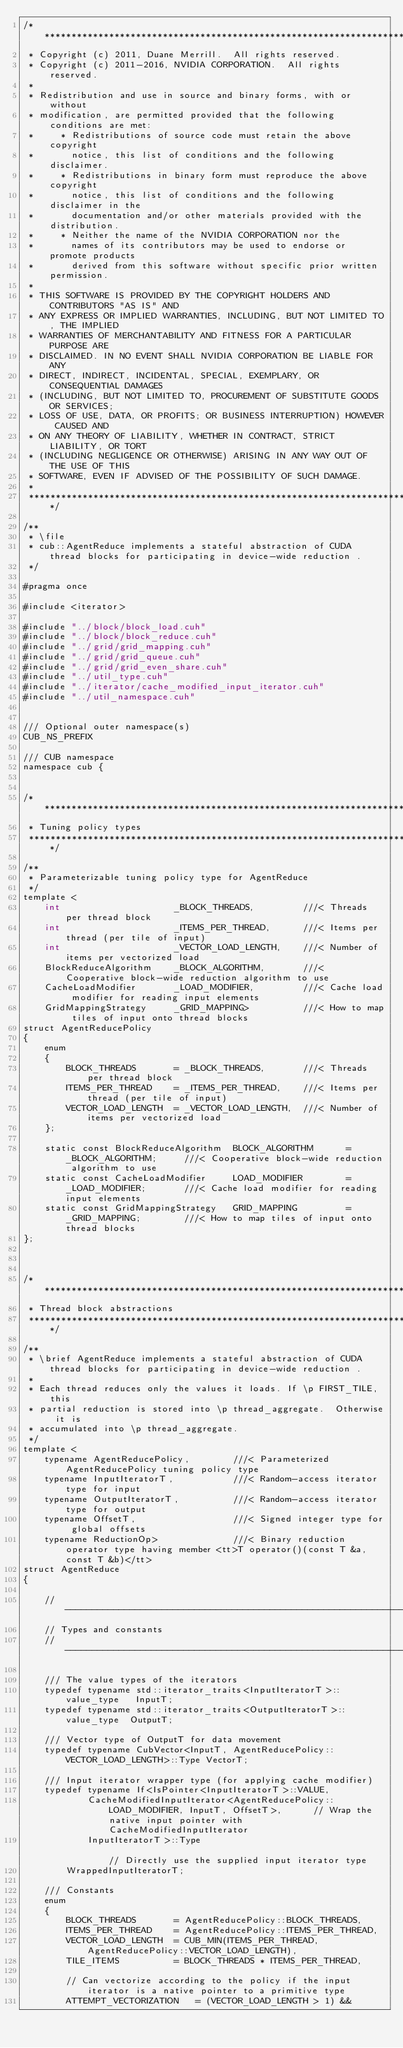Convert code to text. <code><loc_0><loc_0><loc_500><loc_500><_Cuda_>/******************************************************************************
 * Copyright (c) 2011, Duane Merrill.  All rights reserved.
 * Copyright (c) 2011-2016, NVIDIA CORPORATION.  All rights reserved.
 *
 * Redistribution and use in source and binary forms, with or without
 * modification, are permitted provided that the following conditions are met:
 *     * Redistributions of source code must retain the above copyright
 *       notice, this list of conditions and the following disclaimer.
 *     * Redistributions in binary form must reproduce the above copyright
 *       notice, this list of conditions and the following disclaimer in the
 *       documentation and/or other materials provided with the distribution.
 *     * Neither the name of the NVIDIA CORPORATION nor the
 *       names of its contributors may be used to endorse or promote products
 *       derived from this software without specific prior written permission.
 *
 * THIS SOFTWARE IS PROVIDED BY THE COPYRIGHT HOLDERS AND CONTRIBUTORS "AS IS" AND
 * ANY EXPRESS OR IMPLIED WARRANTIES, INCLUDING, BUT NOT LIMITED TO, THE IMPLIED
 * WARRANTIES OF MERCHANTABILITY AND FITNESS FOR A PARTICULAR PURPOSE ARE
 * DISCLAIMED. IN NO EVENT SHALL NVIDIA CORPORATION BE LIABLE FOR ANY
 * DIRECT, INDIRECT, INCIDENTAL, SPECIAL, EXEMPLARY, OR CONSEQUENTIAL DAMAGES
 * (INCLUDING, BUT NOT LIMITED TO, PROCUREMENT OF SUBSTITUTE GOODS OR SERVICES;
 * LOSS OF USE, DATA, OR PROFITS; OR BUSINESS INTERRUPTION) HOWEVER CAUSED AND
 * ON ANY THEORY OF LIABILITY, WHETHER IN CONTRACT, STRICT LIABILITY, OR TORT
 * (INCLUDING NEGLIGENCE OR OTHERWISE) ARISING IN ANY WAY OUT OF THE USE OF THIS
 * SOFTWARE, EVEN IF ADVISED OF THE POSSIBILITY OF SUCH DAMAGE.
 *
 ******************************************************************************/

/**
 * \file
 * cub::AgentReduce implements a stateful abstraction of CUDA thread blocks for participating in device-wide reduction .
 */

#pragma once

#include <iterator>

#include "../block/block_load.cuh"
#include "../block/block_reduce.cuh"
#include "../grid/grid_mapping.cuh"
#include "../grid/grid_queue.cuh"
#include "../grid/grid_even_share.cuh"
#include "../util_type.cuh"
#include "../iterator/cache_modified_input_iterator.cuh"
#include "../util_namespace.cuh"


/// Optional outer namespace(s)
CUB_NS_PREFIX

/// CUB namespace
namespace cub {


/******************************************************************************
 * Tuning policy types
 ******************************************************************************/

/**
 * Parameterizable tuning policy type for AgentReduce
 */
template <
    int                     _BLOCK_THREADS,         ///< Threads per thread block
    int                     _ITEMS_PER_THREAD,      ///< Items per thread (per tile of input)
    int                     _VECTOR_LOAD_LENGTH,    ///< Number of items per vectorized load
    BlockReduceAlgorithm    _BLOCK_ALGORITHM,       ///< Cooperative block-wide reduction algorithm to use
    CacheLoadModifier       _LOAD_MODIFIER,         ///< Cache load modifier for reading input elements
    GridMappingStrategy     _GRID_MAPPING>          ///< How to map tiles of input onto thread blocks
struct AgentReducePolicy
{
    enum
    {
        BLOCK_THREADS       = _BLOCK_THREADS,       ///< Threads per thread block
        ITEMS_PER_THREAD    = _ITEMS_PER_THREAD,    ///< Items per thread (per tile of input)
        VECTOR_LOAD_LENGTH  = _VECTOR_LOAD_LENGTH,  ///< Number of items per vectorized load
    };

    static const BlockReduceAlgorithm  BLOCK_ALGORITHM      = _BLOCK_ALGORITHM;     ///< Cooperative block-wide reduction algorithm to use
    static const CacheLoadModifier     LOAD_MODIFIER        = _LOAD_MODIFIER;       ///< Cache load modifier for reading input elements
    static const GridMappingStrategy   GRID_MAPPING         = _GRID_MAPPING;        ///< How to map tiles of input onto thread blocks
};



/******************************************************************************
 * Thread block abstractions
 ******************************************************************************/

/**
 * \brief AgentReduce implements a stateful abstraction of CUDA thread blocks for participating in device-wide reduction .
 *
 * Each thread reduces only the values it loads. If \p FIRST_TILE, this
 * partial reduction is stored into \p thread_aggregate.  Otherwise it is
 * accumulated into \p thread_aggregate.
 */
template <
    typename AgentReducePolicy,        ///< Parameterized AgentReducePolicy tuning policy type
    typename InputIteratorT,           ///< Random-access iterator type for input
    typename OutputIteratorT,          ///< Random-access iterator type for output
    typename OffsetT,                  ///< Signed integer type for global offsets
    typename ReductionOp>              ///< Binary reduction operator type having member <tt>T operator()(const T &a, const T &b)</tt>
struct AgentReduce
{

    //---------------------------------------------------------------------
    // Types and constants
    //---------------------------------------------------------------------

    /// The value types of the iterators
    typedef typename std::iterator_traits<InputIteratorT>::value_type   InputT;
    typedef typename std::iterator_traits<OutputIteratorT>::value_type  OutputT;

    /// Vector type of OutputT for data movement
    typedef typename CubVector<InputT, AgentReducePolicy::VECTOR_LOAD_LENGTH>::Type VectorT;

    /// Input iterator wrapper type (for applying cache modifier)
    typedef typename If<IsPointer<InputIteratorT>::VALUE,
            CacheModifiedInputIterator<AgentReducePolicy::LOAD_MODIFIER, InputT, OffsetT>,      // Wrap the native input pointer with CacheModifiedInputIterator
            InputIteratorT>::Type                                                               // Directly use the supplied input iterator type
        WrappedInputIteratorT;

    /// Constants
    enum
    {
        BLOCK_THREADS       = AgentReducePolicy::BLOCK_THREADS,
        ITEMS_PER_THREAD    = AgentReducePolicy::ITEMS_PER_THREAD,
        VECTOR_LOAD_LENGTH  = CUB_MIN(ITEMS_PER_THREAD, AgentReducePolicy::VECTOR_LOAD_LENGTH),
        TILE_ITEMS          = BLOCK_THREADS * ITEMS_PER_THREAD,

        // Can vectorize according to the policy if the input iterator is a native pointer to a primitive type
        ATTEMPT_VECTORIZATION   = (VECTOR_LOAD_LENGTH > 1) &&</code> 